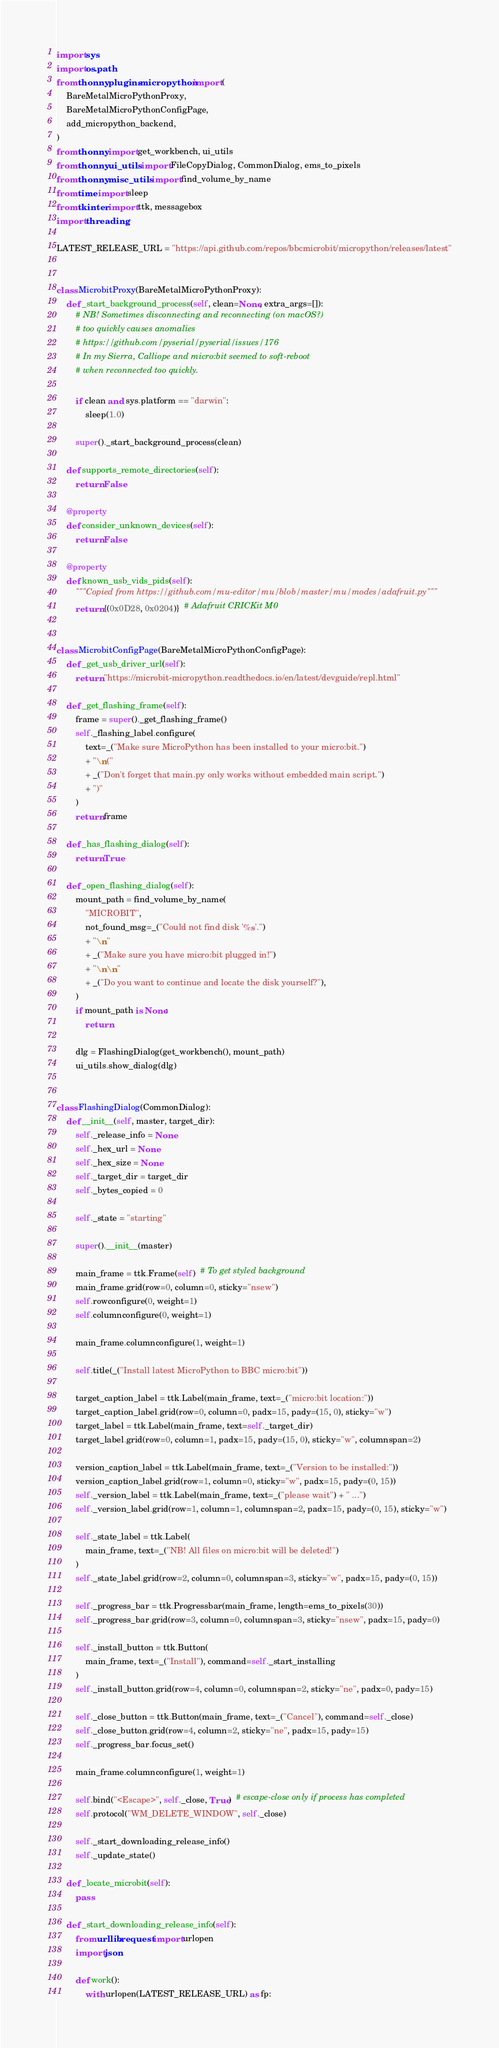Convert code to text. <code><loc_0><loc_0><loc_500><loc_500><_Python_>import sys
import os.path
from thonny.plugins.micropython import (
    BareMetalMicroPythonProxy,
    BareMetalMicroPythonConfigPage,
    add_micropython_backend,
)
from thonny import get_workbench, ui_utils
from thonny.ui_utils import FileCopyDialog, CommonDialog, ems_to_pixels
from thonny.misc_utils import find_volume_by_name
from time import sleep
from tkinter import ttk, messagebox
import threading

LATEST_RELEASE_URL = "https://api.github.com/repos/bbcmicrobit/micropython/releases/latest"


class MicrobitProxy(BareMetalMicroPythonProxy):
    def _start_background_process(self, clean=None, extra_args=[]):
        # NB! Sometimes disconnecting and reconnecting (on macOS?)
        # too quickly causes anomalies
        # https://github.com/pyserial/pyserial/issues/176
        # In my Sierra, Calliope and micro:bit seemed to soft-reboot
        # when reconnected too quickly.

        if clean and sys.platform == "darwin":
            sleep(1.0)

        super()._start_background_process(clean)

    def supports_remote_directories(self):
        return False

    @property
    def consider_unknown_devices(self):
        return False

    @property
    def known_usb_vids_pids(self):
        """Copied from https://github.com/mu-editor/mu/blob/master/mu/modes/adafruit.py"""
        return {(0x0D28, 0x0204)}  # Adafruit CRICKit M0


class MicrobitConfigPage(BareMetalMicroPythonConfigPage):
    def _get_usb_driver_url(self):
        return "https://microbit-micropython.readthedocs.io/en/latest/devguide/repl.html"

    def _get_flashing_frame(self):
        frame = super()._get_flashing_frame()
        self._flashing_label.configure(
            text=_("Make sure MicroPython has been installed to your micro:bit.")
            + "\n("
            + _("Don't forget that main.py only works without embedded main script.")
            + ")"
        )
        return frame

    def _has_flashing_dialog(self):
        return True

    def _open_flashing_dialog(self):
        mount_path = find_volume_by_name(
            "MICROBIT",
            not_found_msg=_("Could not find disk '%s'.")
            + "\n"
            + _("Make sure you have micro:bit plugged in!")
            + "\n\n"
            + _("Do you want to continue and locate the disk yourself?"),
        )
        if mount_path is None:
            return

        dlg = FlashingDialog(get_workbench(), mount_path)
        ui_utils.show_dialog(dlg)


class FlashingDialog(CommonDialog):
    def __init__(self, master, target_dir):
        self._release_info = None
        self._hex_url = None
        self._hex_size = None
        self._target_dir = target_dir
        self._bytes_copied = 0

        self._state = "starting"

        super().__init__(master)

        main_frame = ttk.Frame(self)  # To get styled background
        main_frame.grid(row=0, column=0, sticky="nsew")
        self.rowconfigure(0, weight=1)
        self.columnconfigure(0, weight=1)

        main_frame.columnconfigure(1, weight=1)

        self.title(_("Install latest MicroPython to BBC micro:bit"))

        target_caption_label = ttk.Label(main_frame, text=_("micro:bit location:"))
        target_caption_label.grid(row=0, column=0, padx=15, pady=(15, 0), sticky="w")
        target_label = ttk.Label(main_frame, text=self._target_dir)
        target_label.grid(row=0, column=1, padx=15, pady=(15, 0), sticky="w", columnspan=2)

        version_caption_label = ttk.Label(main_frame, text=_("Version to be installed:"))
        version_caption_label.grid(row=1, column=0, sticky="w", padx=15, pady=(0, 15))
        self._version_label = ttk.Label(main_frame, text=_("please wait") + " ...")
        self._version_label.grid(row=1, column=1, columnspan=2, padx=15, pady=(0, 15), sticky="w")

        self._state_label = ttk.Label(
            main_frame, text=_("NB! All files on micro:bit will be deleted!")
        )
        self._state_label.grid(row=2, column=0, columnspan=3, sticky="w", padx=15, pady=(0, 15))

        self._progress_bar = ttk.Progressbar(main_frame, length=ems_to_pixels(30))
        self._progress_bar.grid(row=3, column=0, columnspan=3, sticky="nsew", padx=15, pady=0)

        self._install_button = ttk.Button(
            main_frame, text=_("Install"), command=self._start_installing
        )
        self._install_button.grid(row=4, column=0, columnspan=2, sticky="ne", padx=0, pady=15)

        self._close_button = ttk.Button(main_frame, text=_("Cancel"), command=self._close)
        self._close_button.grid(row=4, column=2, sticky="ne", padx=15, pady=15)
        self._progress_bar.focus_set()

        main_frame.columnconfigure(1, weight=1)

        self.bind("<Escape>", self._close, True)  # escape-close only if process has completed
        self.protocol("WM_DELETE_WINDOW", self._close)

        self._start_downloading_release_info()
        self._update_state()

    def _locate_microbit(self):
        pass

    def _start_downloading_release_info(self):
        from urllib.request import urlopen
        import json

        def work():
            with urlopen(LATEST_RELEASE_URL) as fp:</code> 